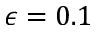Convert formula to latex. <formula><loc_0><loc_0><loc_500><loc_500>\epsilon = 0 . 1</formula> 